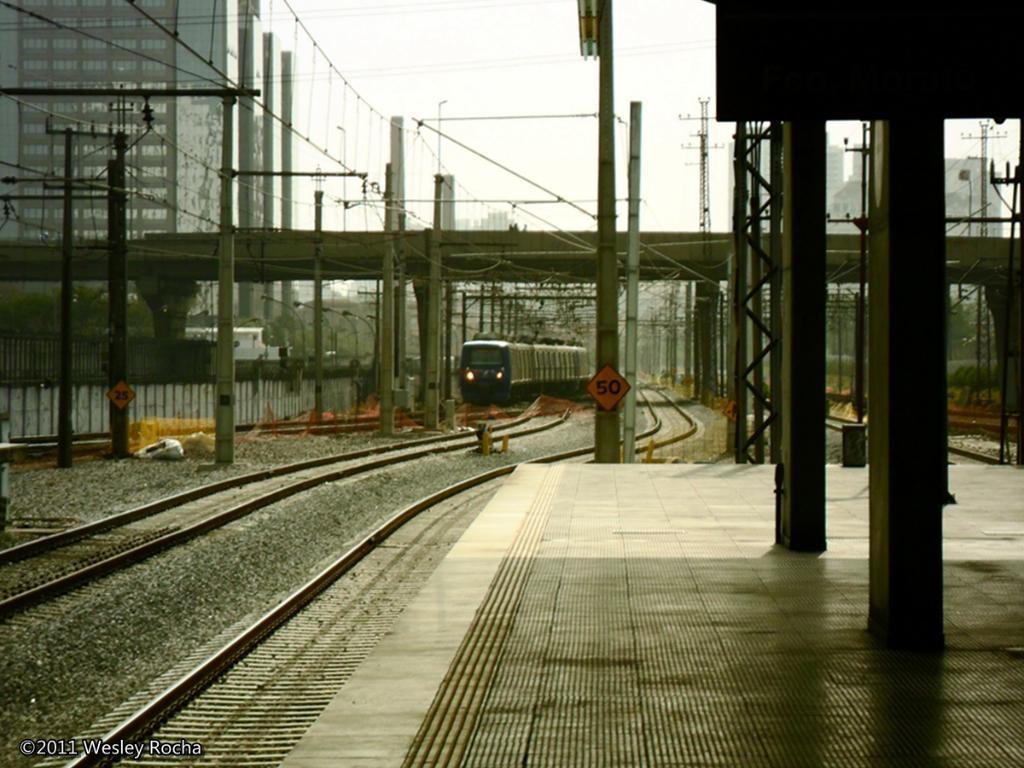Please provide a concise description of this image. In this image we can see a train on the railway track and there are some power poles and we can see a bridge over the railway tracks and on the right side of the image we can see the platform. There are few buildings in the background and at the top we can see the sky. 